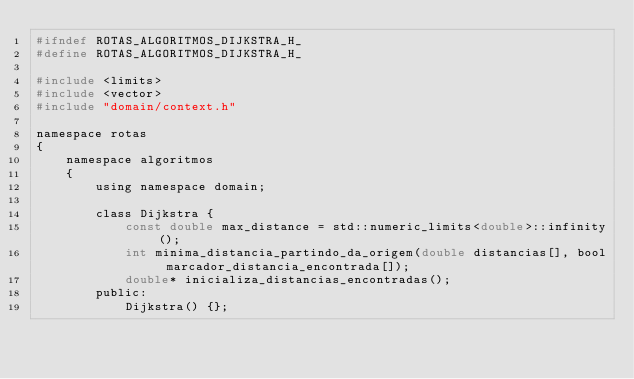<code> <loc_0><loc_0><loc_500><loc_500><_C_>#ifndef ROTAS_ALGORITMOS_DIJKSTRA_H_
#define ROTAS_ALGORITMOS_DIJKSTRA_H_

#include <limits>
#include <vector>
#include "domain/context.h"

namespace rotas
{
	namespace algoritmos
	{
		using namespace domain;

		class Dijkstra {
			const double max_distance = std::numeric_limits<double>::infinity();
			int minima_distancia_partindo_da_origem(double distancias[], bool marcador_distancia_encontrada[]);
			double* inicializa_distancias_encontradas();
		public:
			Dijkstra() {};</code> 